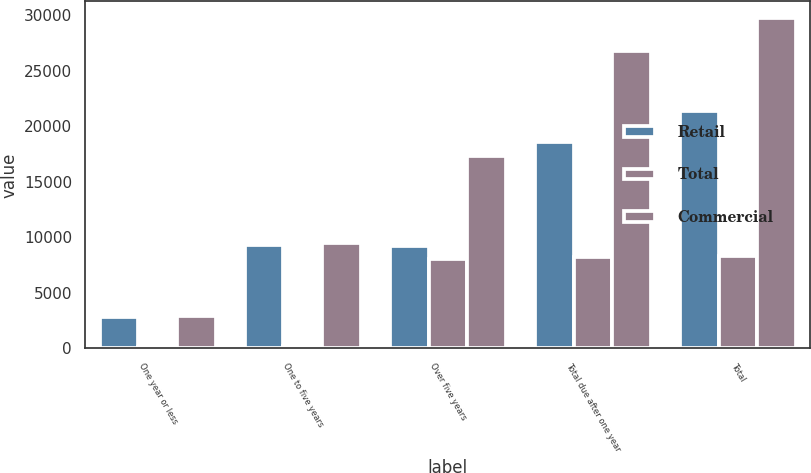Convert chart. <chart><loc_0><loc_0><loc_500><loc_500><stacked_bar_chart><ecel><fcel>One year or less<fcel>One to five years<fcel>Over five years<fcel>Total due after one year<fcel>Total<nl><fcel>Retail<fcel>2848.8<fcel>9298.1<fcel>9258<fcel>18556.1<fcel>21404.9<nl><fcel>Total<fcel>95.7<fcel>188.4<fcel>8055.9<fcel>8244.3<fcel>8340<nl><fcel>Commercial<fcel>2944.5<fcel>9486.5<fcel>17313.9<fcel>26800.4<fcel>29744.9<nl></chart> 